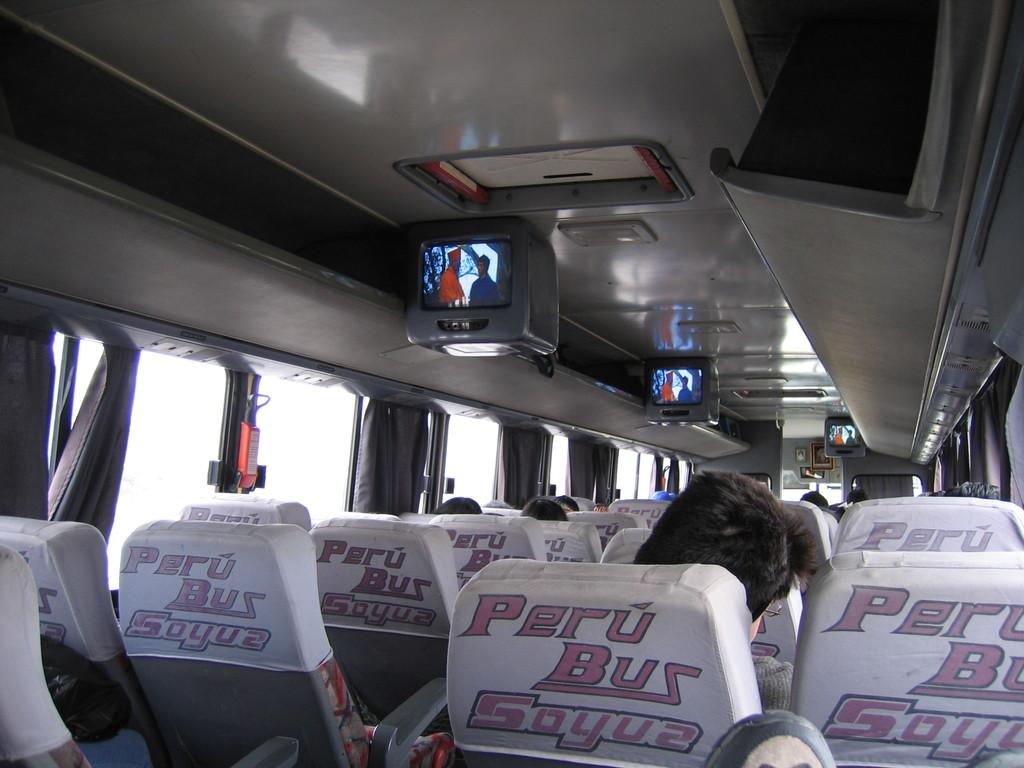What is the main subject of the image? The main subject of the image is a motor vehicle. What are the persons in the image doing? The persons are sitting in the motor vehicle. What features are present in the motor vehicle? The motor vehicle has seats and display screens. What type of window treatment is present in the motor vehicle? The windows of the motor vehicle have curtains. How many kittens are visible on the receipt in the image? There is no receipt or kittens present in the image. What type of cloud is visible through the window of the motor vehicle? There is no cloud visible in the image, as the windows have curtains. 